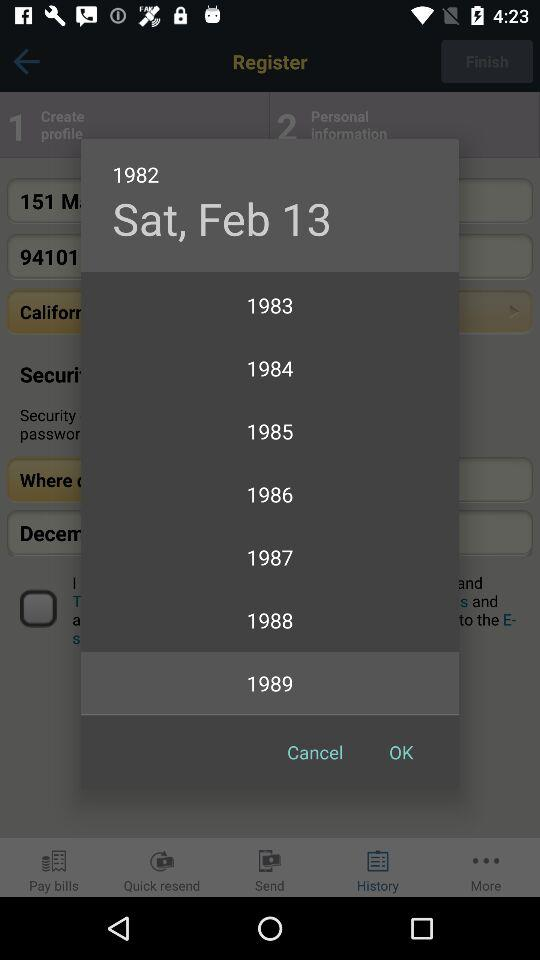What is the day and date? The day is Saturday and the date is February 13, 1982. 